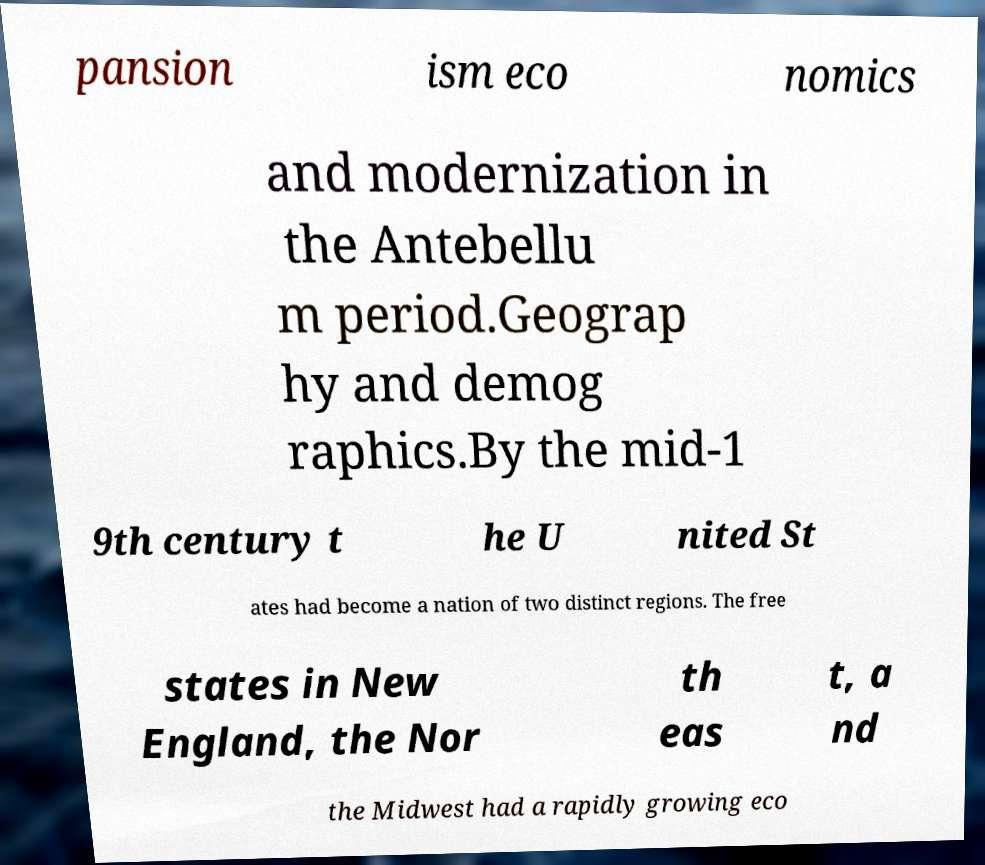What messages or text are displayed in this image? I need them in a readable, typed format. pansion ism eco nomics and modernization in the Antebellu m period.Geograp hy and demog raphics.By the mid-1 9th century t he U nited St ates had become a nation of two distinct regions. The free states in New England, the Nor th eas t, a nd the Midwest had a rapidly growing eco 